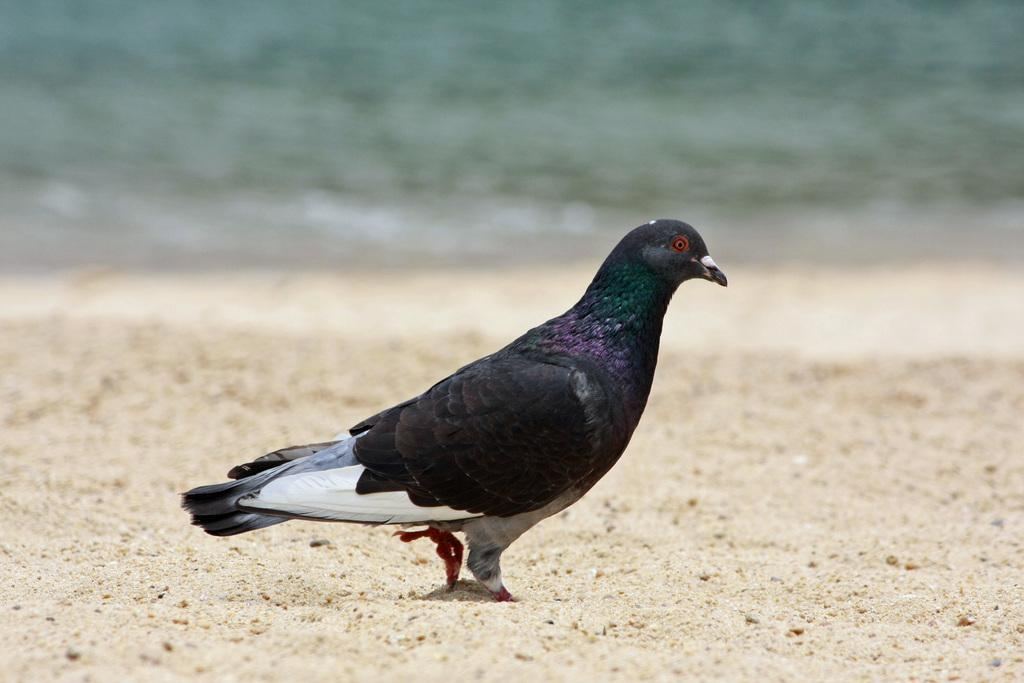What type of animal can be seen in the image? There is a pigeon in the image. What is the pigeon doing in the image? The pigeon is walking on the sand. What can be seen in the background of the image? There is an ocean visible in the background of the image. What color is the sheet that the pigeon is sitting on in the image? There is no sheet present in the image; the pigeon is walking on the sand. 